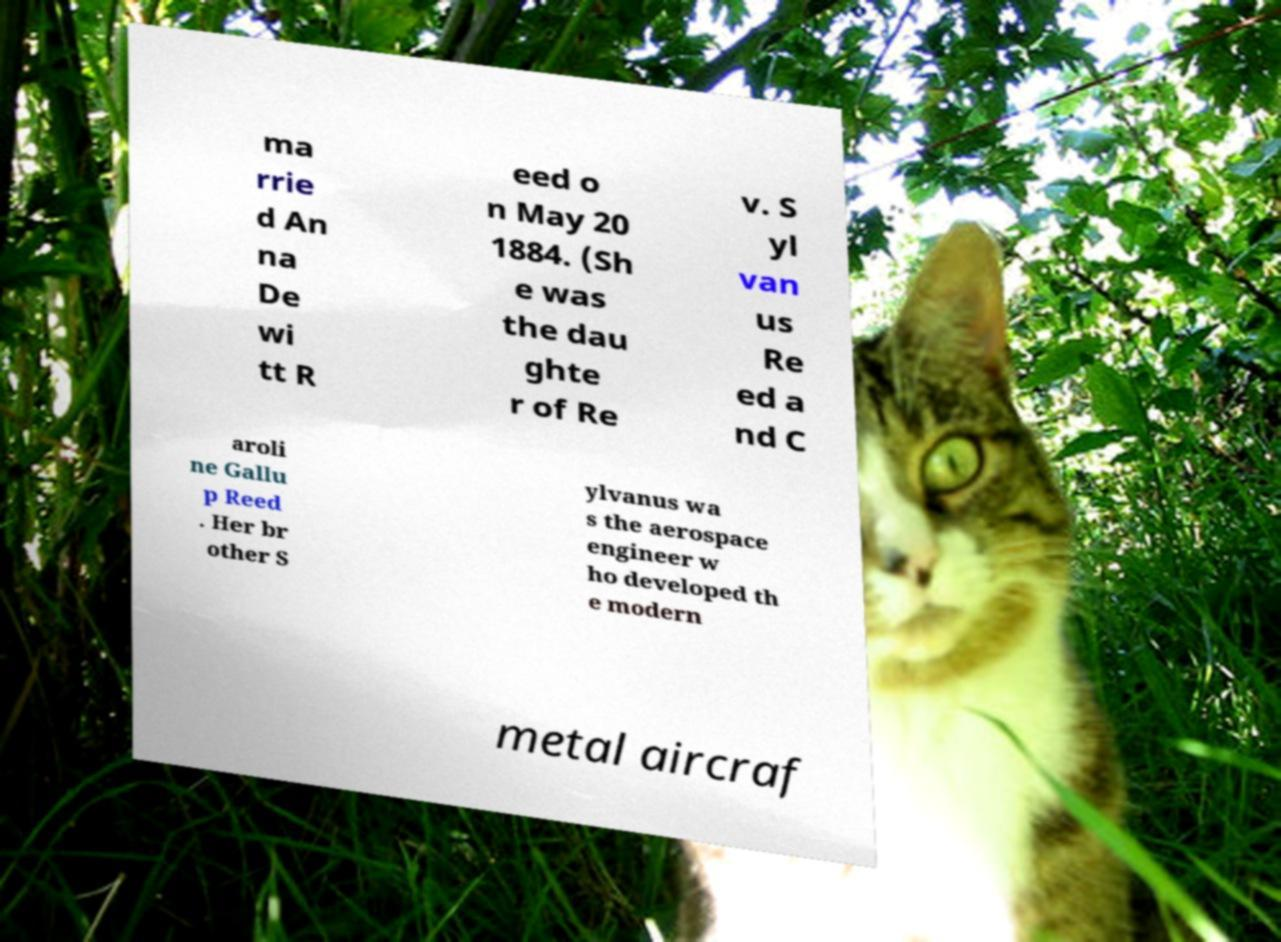Can you read and provide the text displayed in the image?This photo seems to have some interesting text. Can you extract and type it out for me? ma rrie d An na De wi tt R eed o n May 20 1884. (Sh e was the dau ghte r of Re v. S yl van us Re ed a nd C aroli ne Gallu p Reed . Her br other S ylvanus wa s the aerospace engineer w ho developed th e modern metal aircraf 